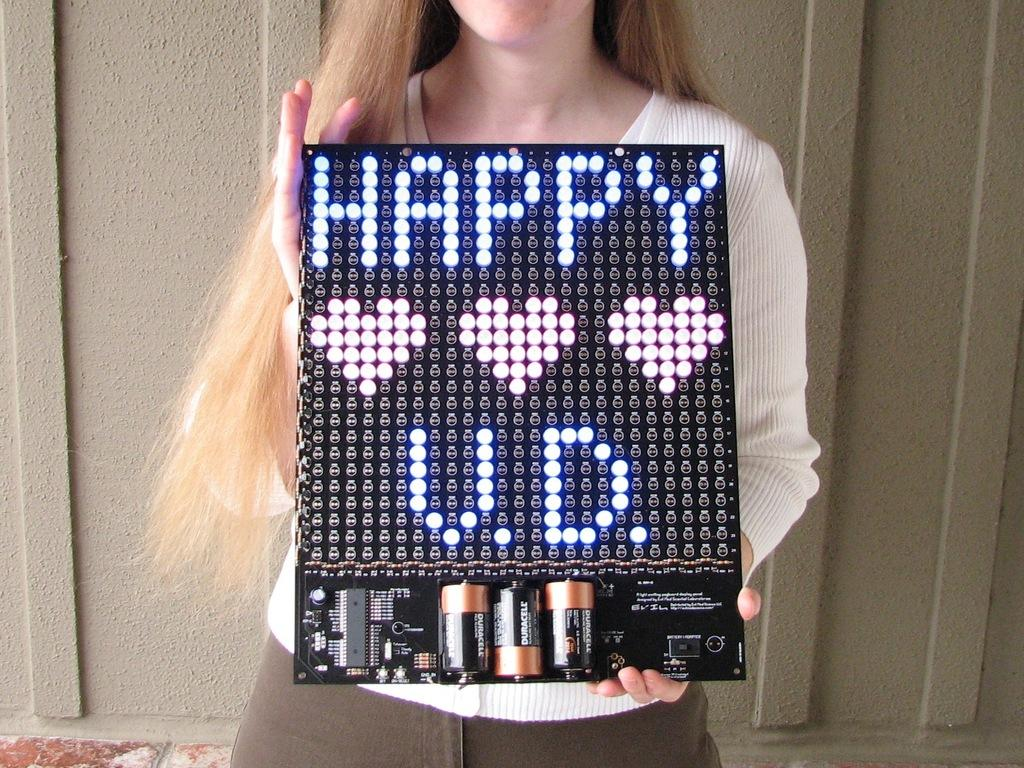What is the person in the image holding? The person is holding a circuit board in the image. What else can be seen in the image besides the circuit board? There are batteries and lights visible in the image. What is in the background of the image? There is a wall in the background of the image. How does the person rub the plate in the image? There is no plate present in the image, and the person is not rubbing anything. 